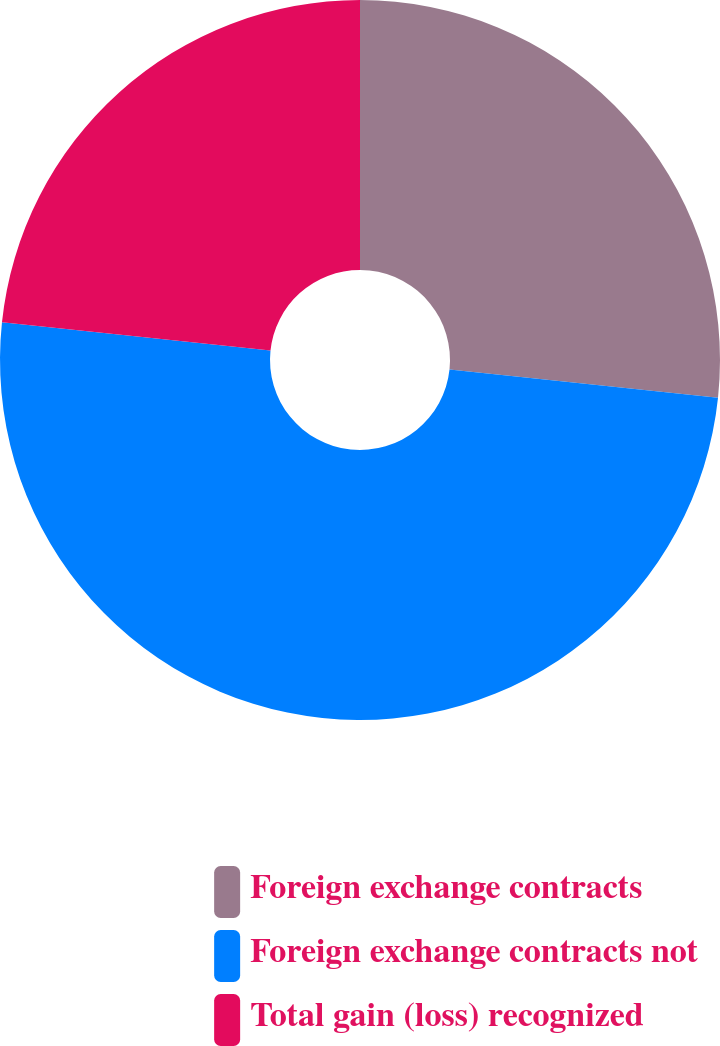Convert chart. <chart><loc_0><loc_0><loc_500><loc_500><pie_chart><fcel>Foreign exchange contracts<fcel>Foreign exchange contracts not<fcel>Total gain (loss) recognized<nl><fcel>26.67%<fcel>50.0%<fcel>23.33%<nl></chart> 